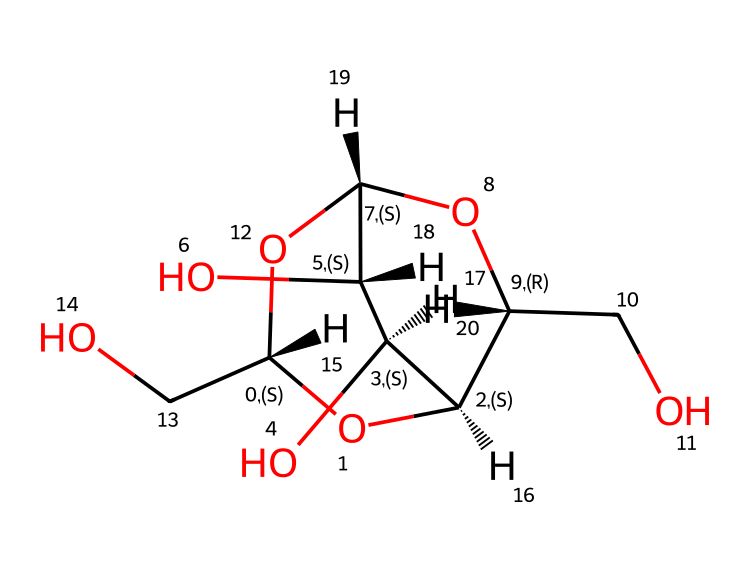What is the chemical name of this structure? The given SMILES represents cellulose, which is a polysaccharide composed of linear chains of glucose units linked by β-1,4-glycosidic bonds.
Answer: cellulose How many carbon atoms are in this molecule? To determine the number of carbon atoms, identify each ‘C’ in the structure. The visual representation indicates there are a total of 6 carbon atoms.
Answer: 6 What type of carbohydrate is cellulose classified as? Cellulose is classified as a polysaccharide due to its composition of multiple monosaccharide units (glucose).
Answer: polysaccharide How many hydroxyl (–OH) groups are present in cellulose? By examining the structure carefully, we can see that cellulose has 3 hydroxyl groups attached to the carbon skeleton.
Answer: 3 What characteristic of cellulose contributes to its structural strength? The β-1,4-glycosidic bonds between glucose units create a linear and rigid structure, contributing to its tensile strength.
Answer: β-1,4-glycosidic bonds How does cellulose interact with water? Cellulose has a high degree of hydrogen bonding among its hydroxyl groups, making it insoluble in water.
Answer: insoluble What role does cellulose play in the environment and human rights documents? Cellulose serves as a fundamental component of paper, promoting sustainability and the durability of documents, including those related to human rights.
Answer: sustainability and durability 